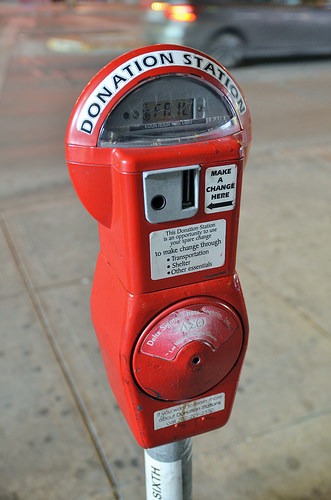<image>
Is the hole next to the plastic? No. The hole is not positioned next to the plastic. They are located in different areas of the scene. 